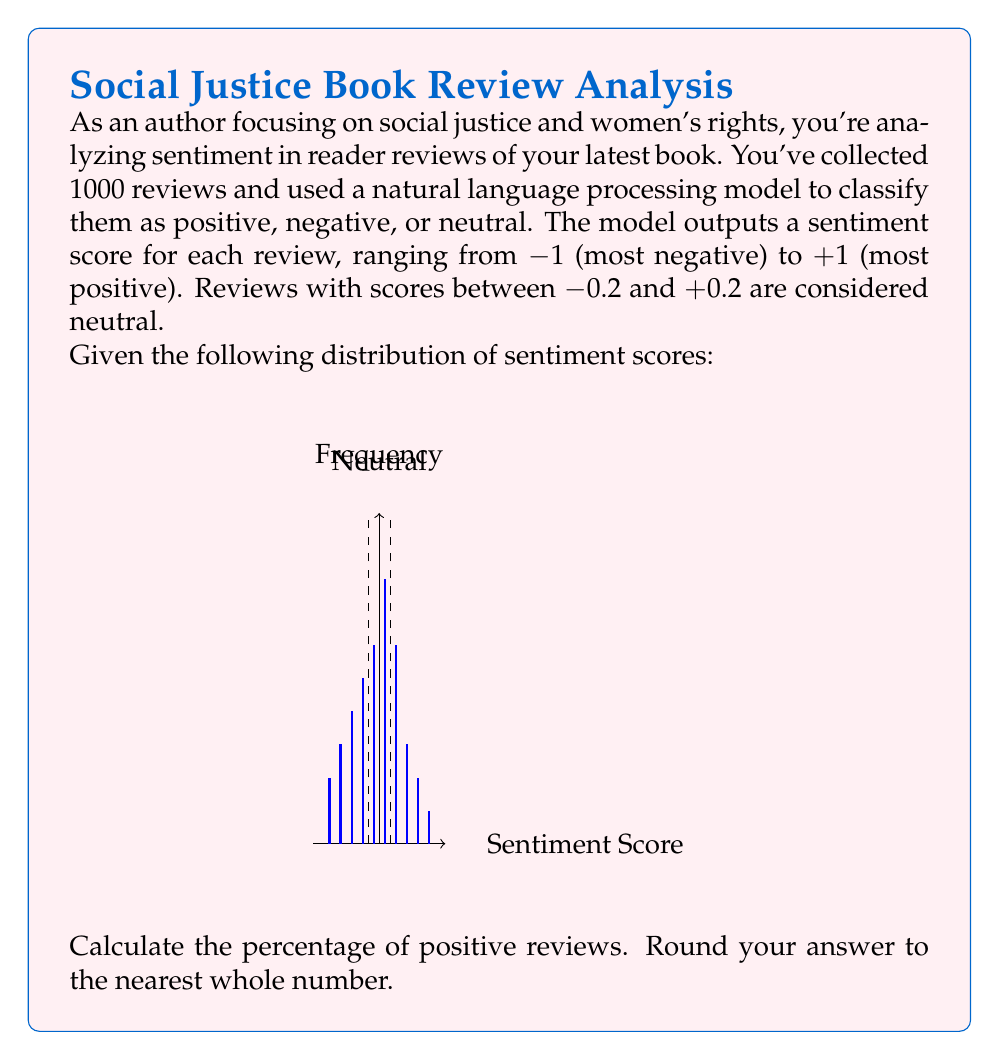What is the answer to this math problem? Let's approach this step-by-step:

1) First, we need to identify which scores represent positive reviews. Based on the given information, scores greater than +0.2 are considered positive.

2) Looking at the histogram, we can see that positive reviews correspond to the last three bars (0.3, 0.5, 0.7, 0.9).

3) Let's sum up the frequencies for these positive reviews:
   $150 + 75 + 50 + 25 = 300$

4) To calculate the percentage, we need the total number of reviews. We're told there are 1000 reviews in total.

5) The formula for percentage is:

   $$ \text{Percentage} = \frac{\text{Number of positive reviews}}{\text{Total number of reviews}} \times 100\% $$

6) Plugging in our values:

   $$ \text{Percentage} = \frac{300}{1000} \times 100\% = 30\% $$

7) The question asks to round to the nearest whole number, but 30 is already a whole number, so no further rounding is necessary.
Answer: 30% 